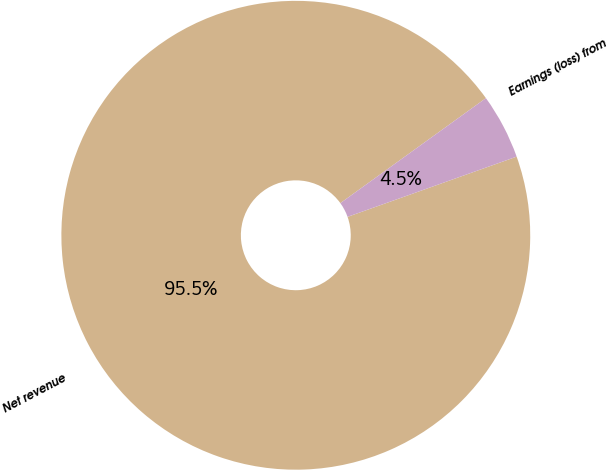<chart> <loc_0><loc_0><loc_500><loc_500><pie_chart><fcel>Net revenue<fcel>Earnings (loss) from<nl><fcel>95.5%<fcel>4.5%<nl></chart> 